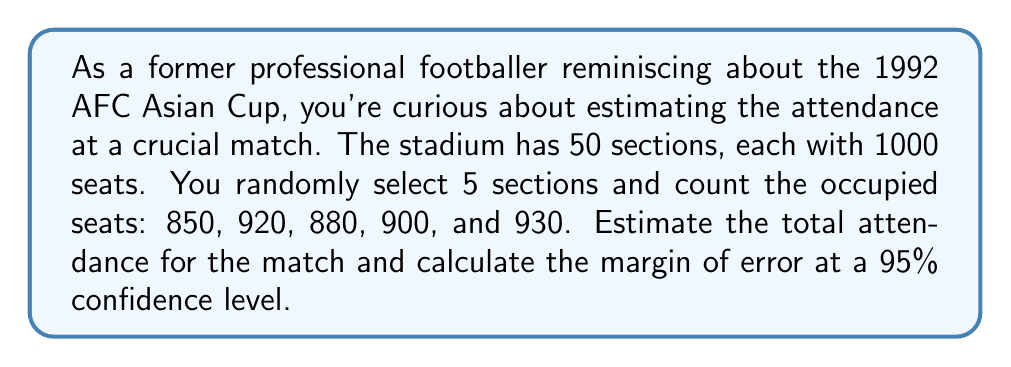Show me your answer to this math problem. 1. Calculate the mean of the sample:
   $\bar{x} = \frac{850 + 920 + 880 + 900 + 930}{5} = 896$

2. Estimate the total attendance:
   $\text{Total Attendance} = 896 \times 50 = 44,800$

3. Calculate the sample standard deviation:
   $$s = \sqrt{\frac{\sum_{i=1}^{n} (x_i - \bar{x})^2}{n-1}}$$
   $$s = \sqrt{\frac{(850-896)^2 + (920-896)^2 + (880-896)^2 + (900-896)^2 + (930-896)^2}{5-1}}$$
   $$s = \sqrt{\frac{2116 + 576 + 256 + 16 + 1156}{4}} = \sqrt{1030} \approx 32.09$$

4. Calculate the standard error:
   $SE = \frac{s}{\sqrt{n}} \times N = \frac{32.09}{\sqrt{5}} \times 50 = 717.85$

5. Find the margin of error (95% confidence level, t-value for 4 df ≈ 2.776):
   $\text{Margin of Error} = t \times SE = 2.776 \times 717.85 \approx 1,992$

6. Express the estimate with margin of error:
   $44,800 \pm 1,992$
Answer: 44,800 ± 1,992 